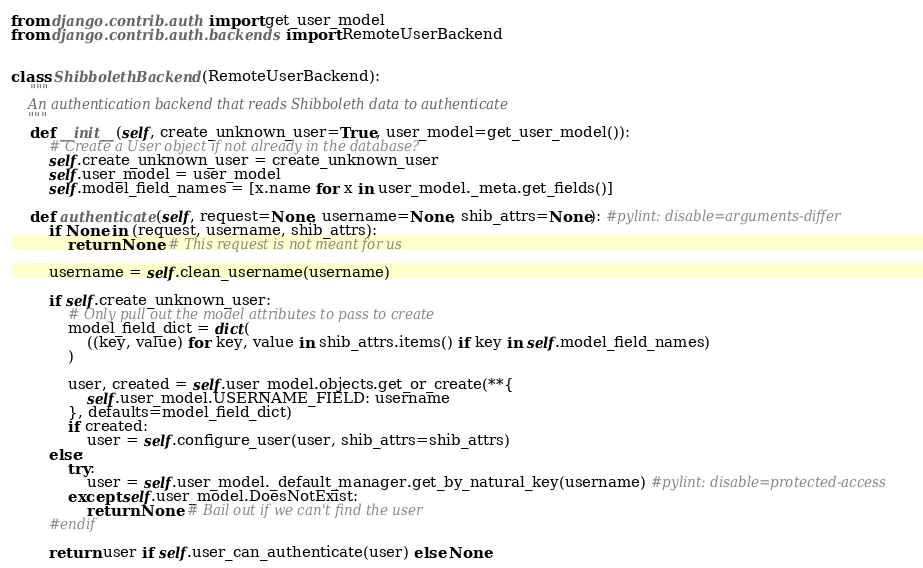Convert code to text. <code><loc_0><loc_0><loc_500><loc_500><_Python_>from django.contrib.auth import get_user_model
from django.contrib.auth.backends import RemoteUserBackend


class ShibbolethBackend(RemoteUserBackend):
	"""
	An authentication backend that reads Shibboleth data to authenticate
	"""
	def __init__(self, create_unknown_user=True, user_model=get_user_model()):
		# Create a User object if not already in the database?
		self.create_unknown_user = create_unknown_user
		self.user_model = user_model
		self.model_field_names = [x.name for x in user_model._meta.get_fields()]

	def authenticate(self, request=None, username=None, shib_attrs=None): #pylint: disable=arguments-differ
		if None in (request, username, shib_attrs):
			return None # This request is not meant for us

		username = self.clean_username(username)

		if self.create_unknown_user:
			# Only pull out the model attributes to pass to create
			model_field_dict = dict(
				((key, value) for key, value in shib_attrs.items() if key in self.model_field_names)
			)

			user, created = self.user_model.objects.get_or_create(**{
				self.user_model.USERNAME_FIELD: username
			}, defaults=model_field_dict)
			if created:
				user = self.configure_user(user, shib_attrs=shib_attrs)
		else:
			try:
				user = self.user_model._default_manager.get_by_natural_key(username) #pylint: disable=protected-access
			except self.user_model.DoesNotExist:
				return None # Bail out if we can't find the user
		#endif

		return user if self.user_can_authenticate(user) else None
</code> 